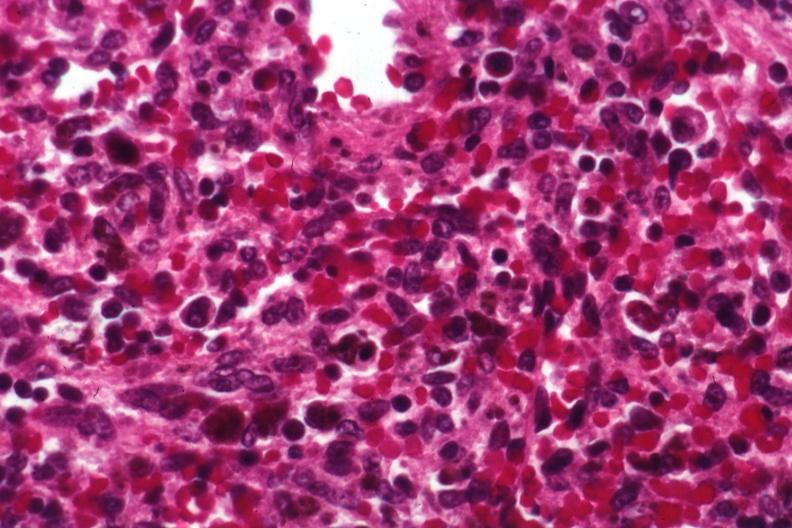s dysplastic present?
Answer the question using a single word or phrase. No 